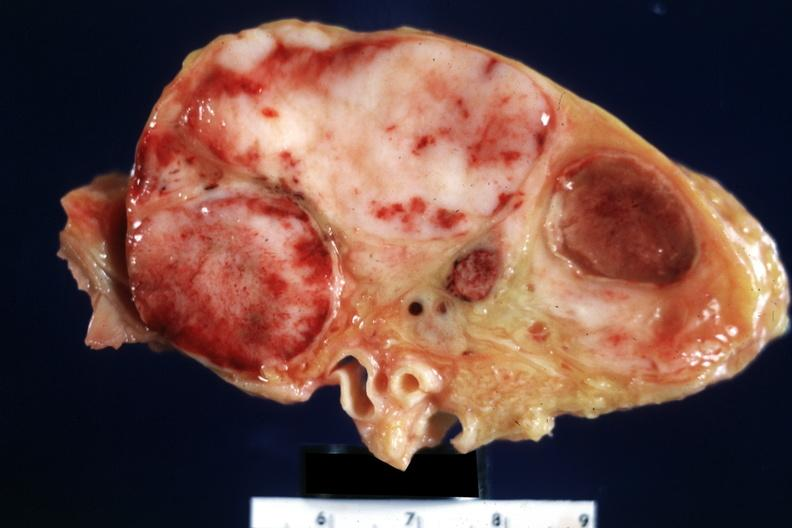what is present?
Answer the question using a single word or phrase. Lymph node 